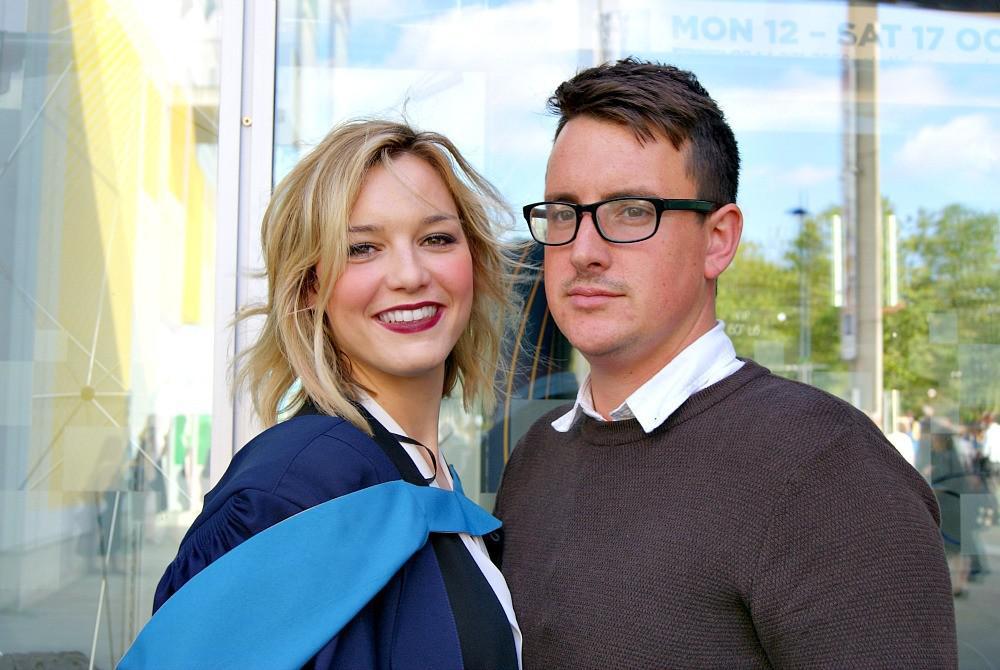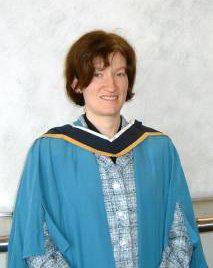The first image is the image on the left, the second image is the image on the right. Examine the images to the left and right. Is the description "A smiling woman with short hair is seen from the front wearing a sky blue gown, open to show her clothing, with dark navy blue and yellow at her neck." accurate? Answer yes or no. Yes. The first image is the image on the left, the second image is the image on the right. Analyze the images presented: Is the assertion "One of the images shows a man wearing a blue and yellow stole holding a rolled up diploma in his hands that is tied with a red ribbon." valid? Answer yes or no. No. 